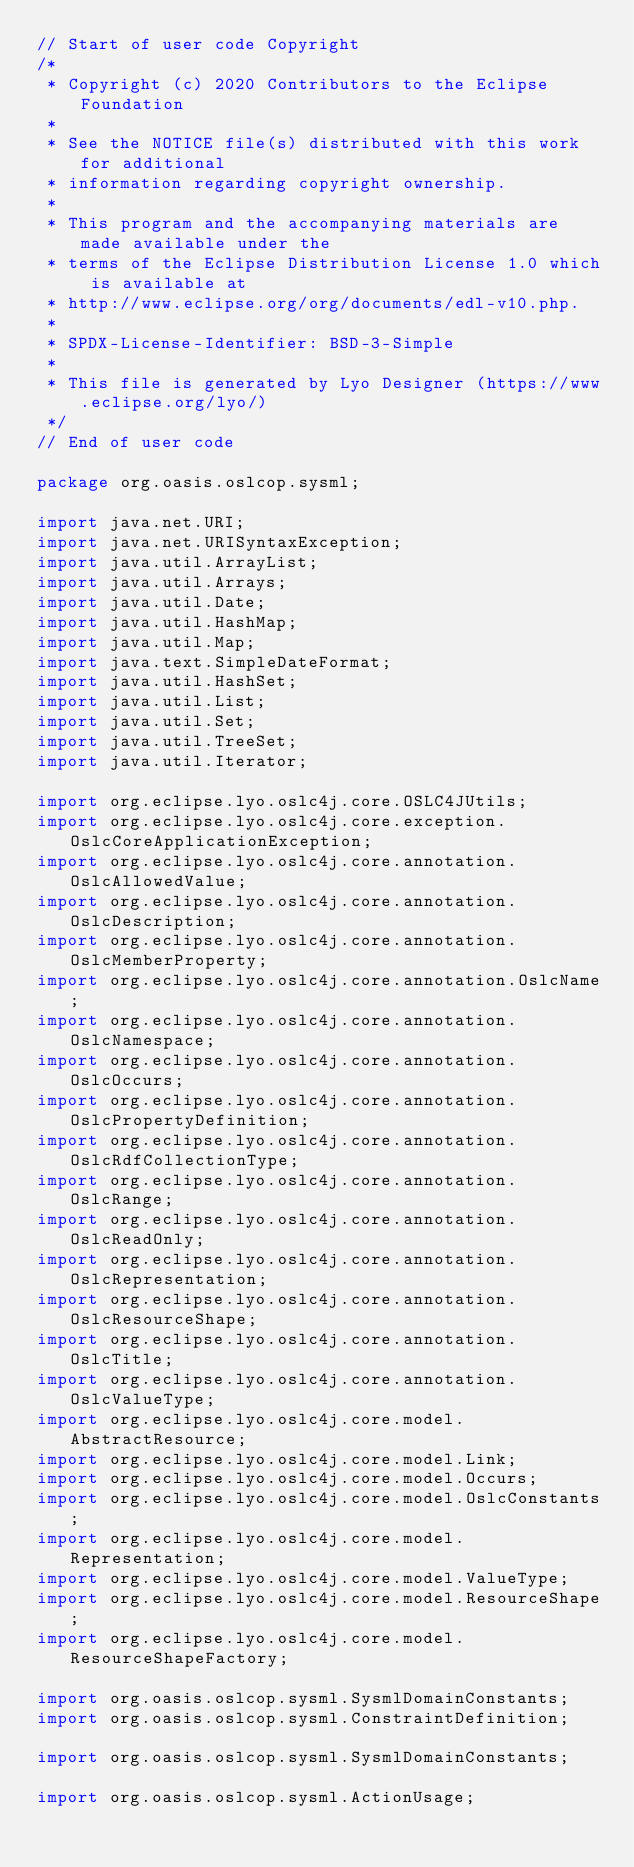Convert code to text. <code><loc_0><loc_0><loc_500><loc_500><_Java_>// Start of user code Copyright
/*
 * Copyright (c) 2020 Contributors to the Eclipse Foundation
 *
 * See the NOTICE file(s) distributed with this work for additional
 * information regarding copyright ownership.
 *
 * This program and the accompanying materials are made available under the
 * terms of the Eclipse Distribution License 1.0 which is available at
 * http://www.eclipse.org/org/documents/edl-v10.php.
 *
 * SPDX-License-Identifier: BSD-3-Simple
 *
 * This file is generated by Lyo Designer (https://www.eclipse.org/lyo/)
 */
// End of user code

package org.oasis.oslcop.sysml;

import java.net.URI;
import java.net.URISyntaxException;
import java.util.ArrayList;
import java.util.Arrays;
import java.util.Date;
import java.util.HashMap;
import java.util.Map;
import java.text.SimpleDateFormat;
import java.util.HashSet;
import java.util.List;
import java.util.Set;
import java.util.TreeSet;
import java.util.Iterator;

import org.eclipse.lyo.oslc4j.core.OSLC4JUtils;
import org.eclipse.lyo.oslc4j.core.exception.OslcCoreApplicationException;
import org.eclipse.lyo.oslc4j.core.annotation.OslcAllowedValue;
import org.eclipse.lyo.oslc4j.core.annotation.OslcDescription;
import org.eclipse.lyo.oslc4j.core.annotation.OslcMemberProperty;
import org.eclipse.lyo.oslc4j.core.annotation.OslcName;
import org.eclipse.lyo.oslc4j.core.annotation.OslcNamespace;
import org.eclipse.lyo.oslc4j.core.annotation.OslcOccurs;
import org.eclipse.lyo.oslc4j.core.annotation.OslcPropertyDefinition;
import org.eclipse.lyo.oslc4j.core.annotation.OslcRdfCollectionType;
import org.eclipse.lyo.oslc4j.core.annotation.OslcRange;
import org.eclipse.lyo.oslc4j.core.annotation.OslcReadOnly;
import org.eclipse.lyo.oslc4j.core.annotation.OslcRepresentation;
import org.eclipse.lyo.oslc4j.core.annotation.OslcResourceShape;
import org.eclipse.lyo.oslc4j.core.annotation.OslcTitle;
import org.eclipse.lyo.oslc4j.core.annotation.OslcValueType;
import org.eclipse.lyo.oslc4j.core.model.AbstractResource;
import org.eclipse.lyo.oslc4j.core.model.Link;
import org.eclipse.lyo.oslc4j.core.model.Occurs;
import org.eclipse.lyo.oslc4j.core.model.OslcConstants;
import org.eclipse.lyo.oslc4j.core.model.Representation;
import org.eclipse.lyo.oslc4j.core.model.ValueType;
import org.eclipse.lyo.oslc4j.core.model.ResourceShape;
import org.eclipse.lyo.oslc4j.core.model.ResourceShapeFactory;

import org.oasis.oslcop.sysml.SysmlDomainConstants;
import org.oasis.oslcop.sysml.ConstraintDefinition;

import org.oasis.oslcop.sysml.SysmlDomainConstants;

import org.oasis.oslcop.sysml.ActionUsage;</code> 